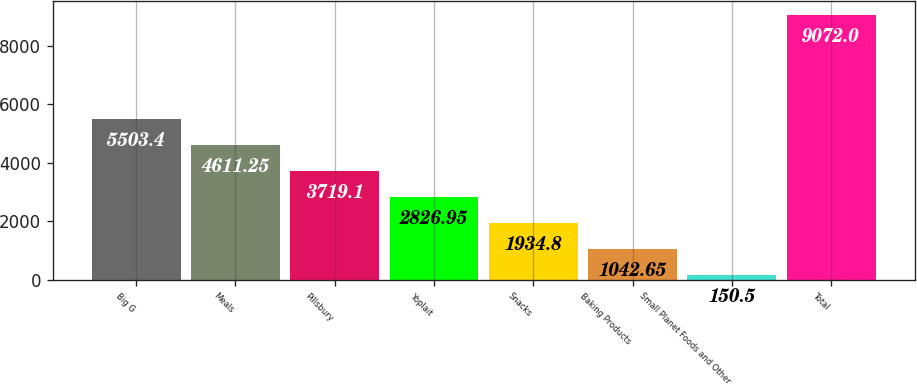Convert chart. <chart><loc_0><loc_0><loc_500><loc_500><bar_chart><fcel>Big G<fcel>Meals<fcel>Pillsbury<fcel>Yoplait<fcel>Snacks<fcel>Baking Products<fcel>Small Planet Foods and Other<fcel>Total<nl><fcel>5503.4<fcel>4611.25<fcel>3719.1<fcel>2826.95<fcel>1934.8<fcel>1042.65<fcel>150.5<fcel>9072<nl></chart> 